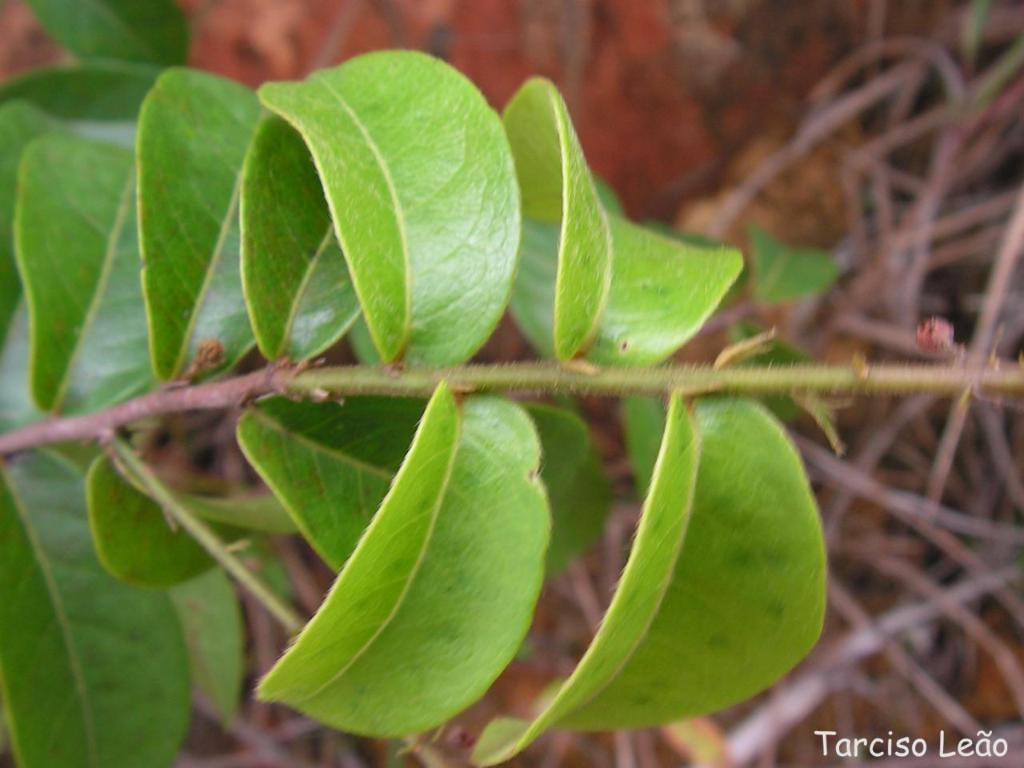What is the main subject in the center of the image? There is a plant in the center of the image. Can you describe the background of the image? The background of the image is blurry. What type of cracker is being used as a prop in the image? There is no cracker present in the image. What is the purpose of the hope in the image? There is no mention of hope in the image; it is a plant and a blurry background. 